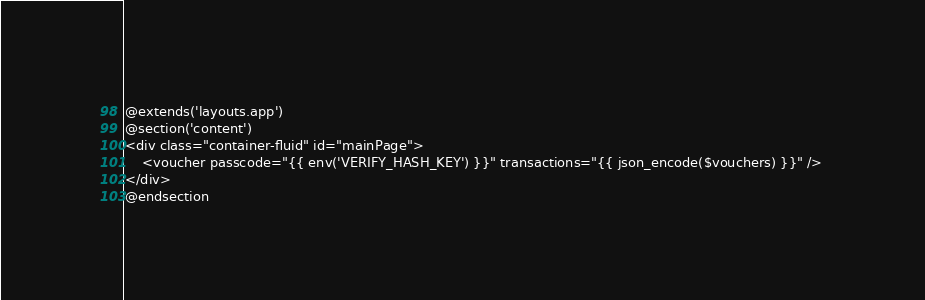<code> <loc_0><loc_0><loc_500><loc_500><_PHP_>@extends('layouts.app')
@section('content')
<div class="container-fluid" id="mainPage">
    <voucher passcode="{{ env('VERIFY_HASH_KEY') }}" transactions="{{ json_encode($vouchers) }}" /> 
</div>
@endsection
</code> 